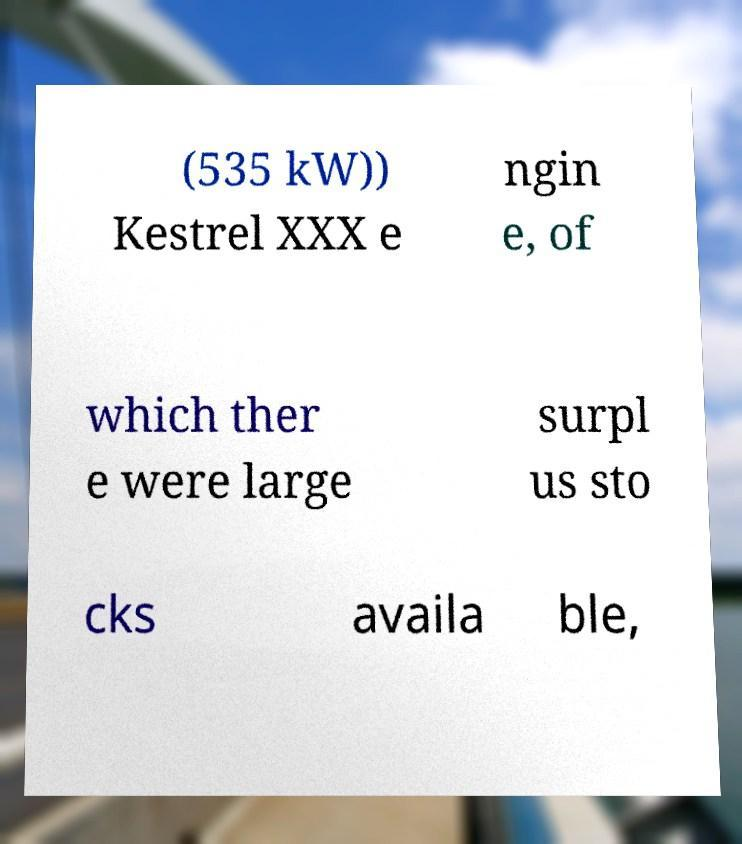Can you accurately transcribe the text from the provided image for me? (535 kW)) Kestrel XXX e ngin e, of which ther e were large surpl us sto cks availa ble, 